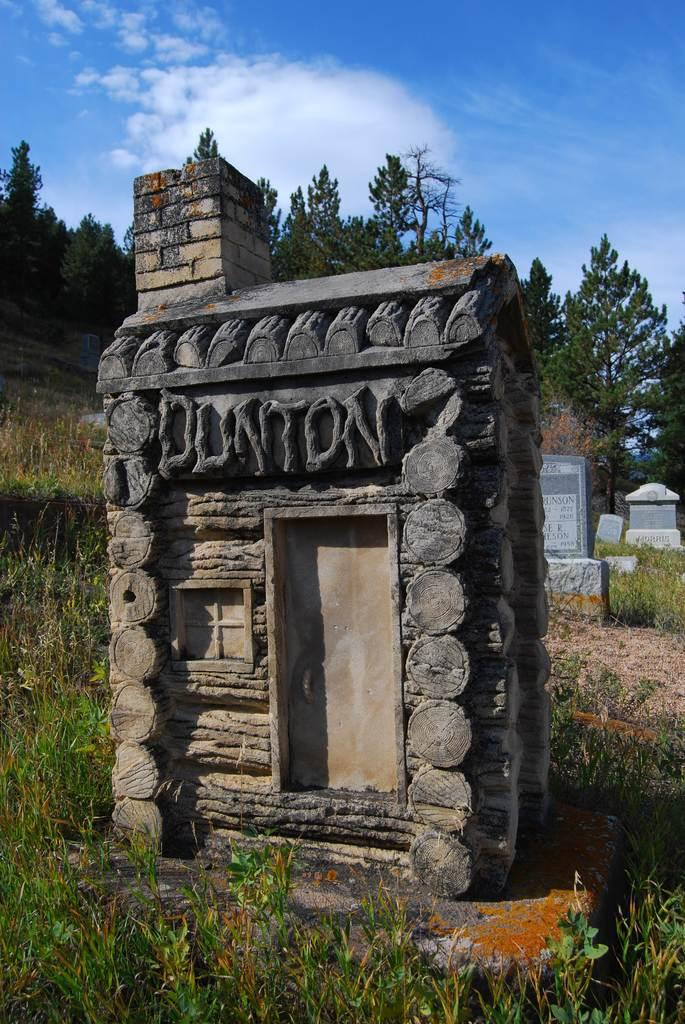<image>
Relay a brief, clear account of the picture shown. A little fake log cabin says DUNTON on the side of it. 